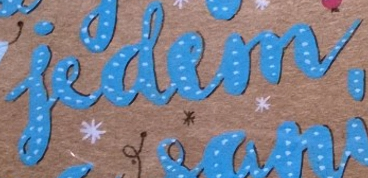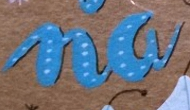Read the text content from these images in order, separated by a semicolon. iedem; na 